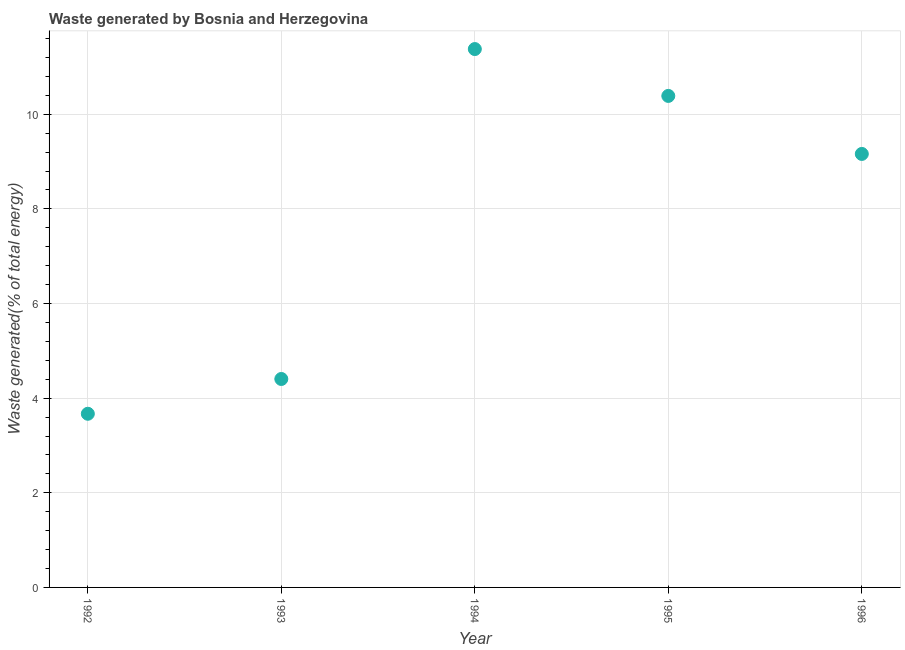What is the amount of waste generated in 1992?
Provide a succinct answer. 3.67. Across all years, what is the maximum amount of waste generated?
Your answer should be compact. 11.38. Across all years, what is the minimum amount of waste generated?
Provide a short and direct response. 3.67. In which year was the amount of waste generated maximum?
Make the answer very short. 1994. What is the sum of the amount of waste generated?
Provide a short and direct response. 39. What is the difference between the amount of waste generated in 1993 and 1995?
Offer a very short reply. -5.98. What is the average amount of waste generated per year?
Ensure brevity in your answer.  7.8. What is the median amount of waste generated?
Your answer should be very brief. 9.16. In how many years, is the amount of waste generated greater than 0.8 %?
Provide a short and direct response. 5. What is the ratio of the amount of waste generated in 1994 to that in 1995?
Your answer should be compact. 1.1. Is the amount of waste generated in 1994 less than that in 1996?
Keep it short and to the point. No. Is the difference between the amount of waste generated in 1993 and 1996 greater than the difference between any two years?
Give a very brief answer. No. What is the difference between the highest and the second highest amount of waste generated?
Offer a very short reply. 0.99. Is the sum of the amount of waste generated in 1992 and 1993 greater than the maximum amount of waste generated across all years?
Provide a short and direct response. No. What is the difference between the highest and the lowest amount of waste generated?
Provide a succinct answer. 7.71. In how many years, is the amount of waste generated greater than the average amount of waste generated taken over all years?
Provide a succinct answer. 3. How many dotlines are there?
Offer a terse response. 1. How many years are there in the graph?
Your answer should be very brief. 5. What is the difference between two consecutive major ticks on the Y-axis?
Make the answer very short. 2. Are the values on the major ticks of Y-axis written in scientific E-notation?
Your response must be concise. No. Does the graph contain any zero values?
Give a very brief answer. No. What is the title of the graph?
Provide a short and direct response. Waste generated by Bosnia and Herzegovina. What is the label or title of the X-axis?
Ensure brevity in your answer.  Year. What is the label or title of the Y-axis?
Give a very brief answer. Waste generated(% of total energy). What is the Waste generated(% of total energy) in 1992?
Give a very brief answer. 3.67. What is the Waste generated(% of total energy) in 1993?
Provide a short and direct response. 4.41. What is the Waste generated(% of total energy) in 1994?
Your response must be concise. 11.38. What is the Waste generated(% of total energy) in 1995?
Provide a short and direct response. 10.39. What is the Waste generated(% of total energy) in 1996?
Offer a very short reply. 9.16. What is the difference between the Waste generated(% of total energy) in 1992 and 1993?
Provide a short and direct response. -0.74. What is the difference between the Waste generated(% of total energy) in 1992 and 1994?
Keep it short and to the point. -7.71. What is the difference between the Waste generated(% of total energy) in 1992 and 1995?
Ensure brevity in your answer.  -6.72. What is the difference between the Waste generated(% of total energy) in 1992 and 1996?
Provide a succinct answer. -5.49. What is the difference between the Waste generated(% of total energy) in 1993 and 1994?
Your answer should be very brief. -6.97. What is the difference between the Waste generated(% of total energy) in 1993 and 1995?
Make the answer very short. -5.98. What is the difference between the Waste generated(% of total energy) in 1993 and 1996?
Your answer should be very brief. -4.76. What is the difference between the Waste generated(% of total energy) in 1994 and 1995?
Keep it short and to the point. 0.99. What is the difference between the Waste generated(% of total energy) in 1994 and 1996?
Give a very brief answer. 2.22. What is the difference between the Waste generated(% of total energy) in 1995 and 1996?
Provide a succinct answer. 1.23. What is the ratio of the Waste generated(% of total energy) in 1992 to that in 1993?
Your response must be concise. 0.83. What is the ratio of the Waste generated(% of total energy) in 1992 to that in 1994?
Make the answer very short. 0.32. What is the ratio of the Waste generated(% of total energy) in 1992 to that in 1995?
Provide a short and direct response. 0.35. What is the ratio of the Waste generated(% of total energy) in 1992 to that in 1996?
Offer a terse response. 0.4. What is the ratio of the Waste generated(% of total energy) in 1993 to that in 1994?
Provide a short and direct response. 0.39. What is the ratio of the Waste generated(% of total energy) in 1993 to that in 1995?
Ensure brevity in your answer.  0.42. What is the ratio of the Waste generated(% of total energy) in 1993 to that in 1996?
Give a very brief answer. 0.48. What is the ratio of the Waste generated(% of total energy) in 1994 to that in 1995?
Keep it short and to the point. 1.09. What is the ratio of the Waste generated(% of total energy) in 1994 to that in 1996?
Your answer should be compact. 1.24. What is the ratio of the Waste generated(% of total energy) in 1995 to that in 1996?
Make the answer very short. 1.13. 